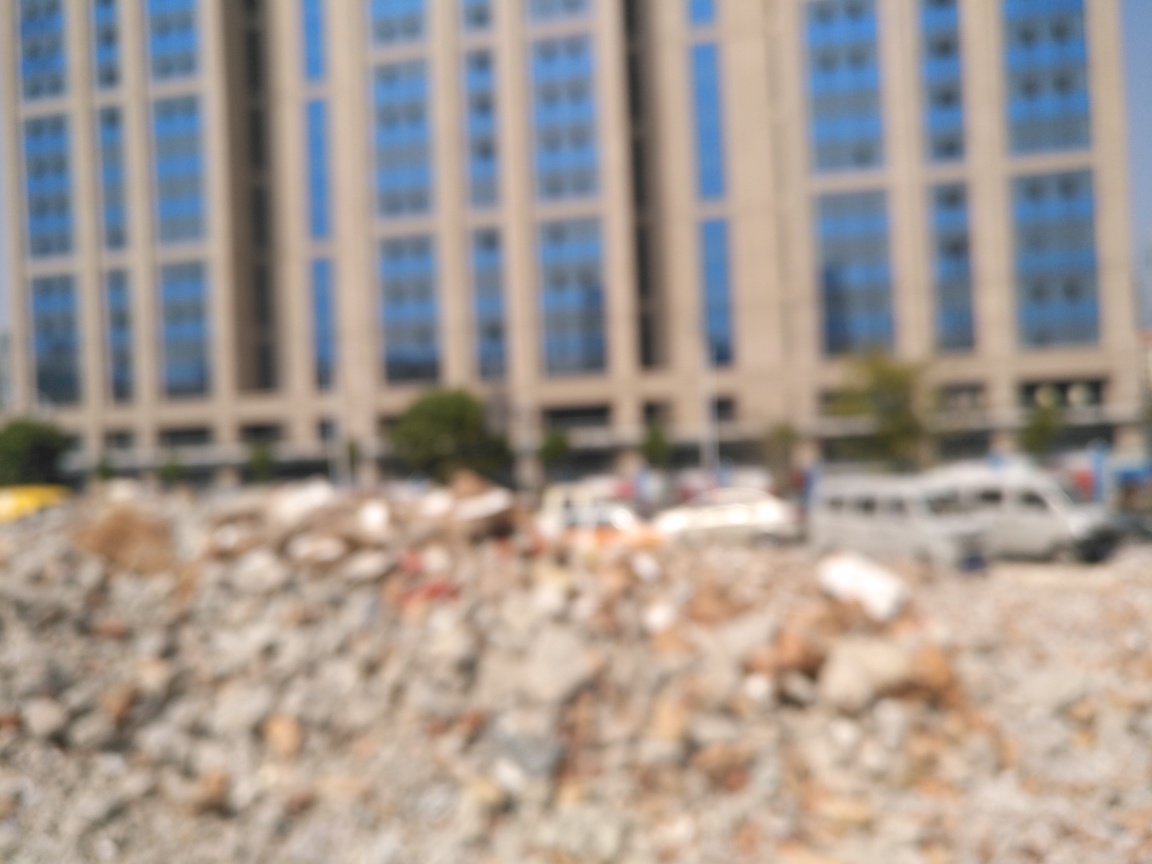How might this image be used in different contexts? This image could be utilized in various contexts. For artistic purposes, it could represent abstraction or the concept of obscured reality. In journalism or advocacy, it might serve as a visual metaphor for the consequences of urban development, gentrification, or loss of cultural heritage. In education, it could prompt discussions on photography techniques, like the impact of focus on perception. 